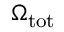<formula> <loc_0><loc_0><loc_500><loc_500>\Omega _ { t o t }</formula> 